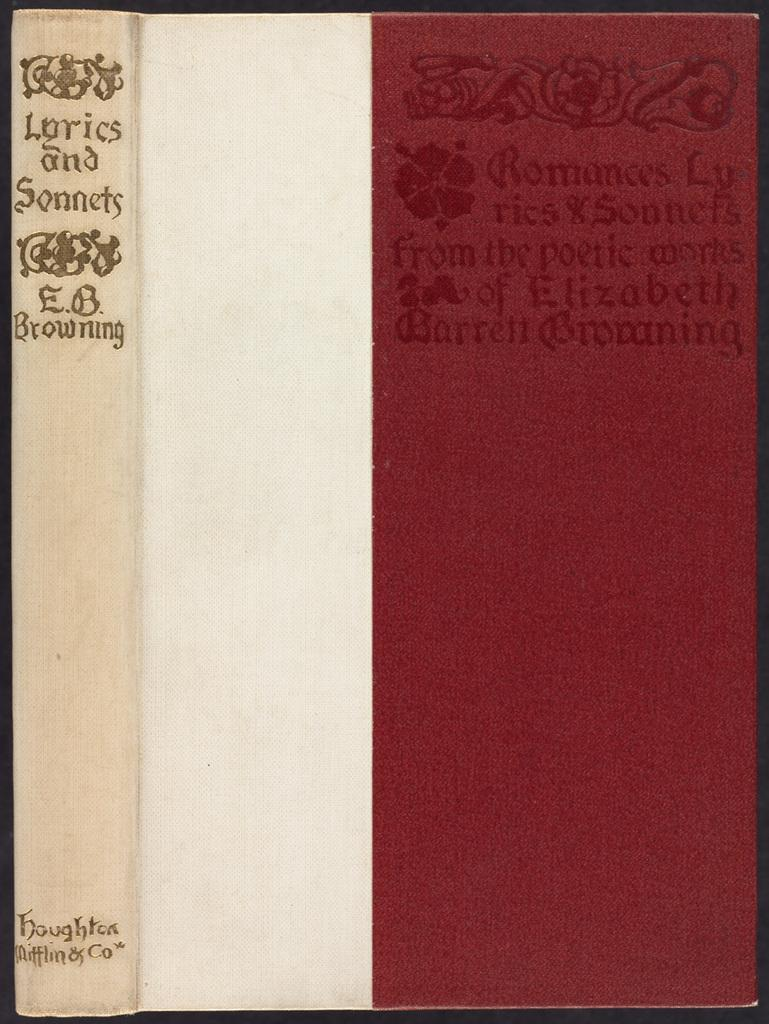<image>
Summarize the visual content of the image. A book of lyrics and sonnets has a white spine and red on the cover. 